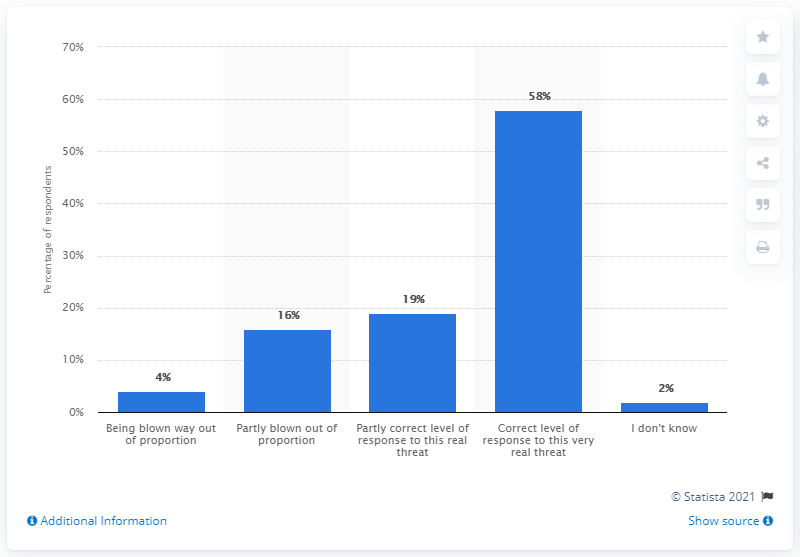Draw attention to some important aspects in this diagram. According to a survey conducted in March 2020, approximately 4% of Canadian adults believed that the coronavirus pandemic was being exaggerated or overblown. 